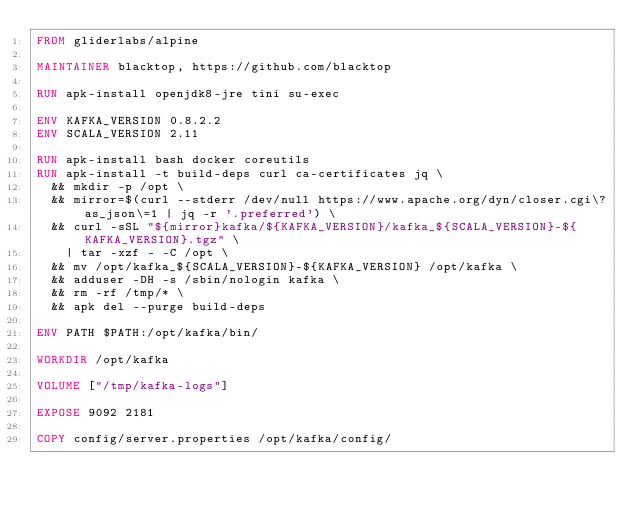Convert code to text. <code><loc_0><loc_0><loc_500><loc_500><_Dockerfile_>FROM gliderlabs/alpine

MAINTAINER blacktop, https://github.com/blacktop

RUN apk-install openjdk8-jre tini su-exec

ENV KAFKA_VERSION 0.8.2.2
ENV SCALA_VERSION 2.11

RUN apk-install bash docker coreutils
RUN apk-install -t build-deps curl ca-certificates jq \
  && mkdir -p /opt \
	&& mirror=$(curl --stderr /dev/null https://www.apache.org/dyn/closer.cgi\?as_json\=1 | jq -r '.preferred') \
	&& curl -sSL "${mirror}kafka/${KAFKA_VERSION}/kafka_${SCALA_VERSION}-${KAFKA_VERSION}.tgz" \
		| tar -xzf - -C /opt \
	&& mv /opt/kafka_${SCALA_VERSION}-${KAFKA_VERSION} /opt/kafka \
  && adduser -DH -s /sbin/nologin kafka \
  && rm -rf /tmp/* \
  && apk del --purge build-deps

ENV PATH $PATH:/opt/kafka/bin/

WORKDIR /opt/kafka

VOLUME ["/tmp/kafka-logs"]

EXPOSE 9092 2181

COPY config/server.properties /opt/kafka/config/</code> 